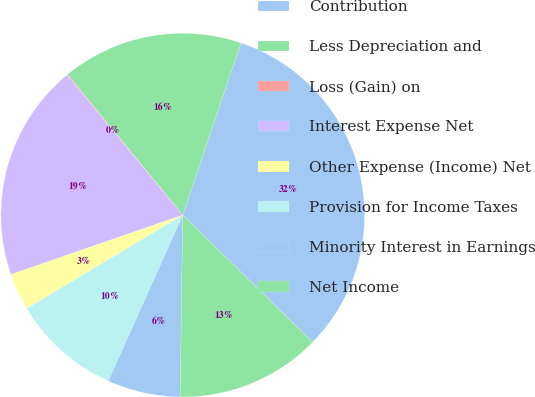<chart> <loc_0><loc_0><loc_500><loc_500><pie_chart><fcel>Contribution<fcel>Less Depreciation and<fcel>Loss (Gain) on<fcel>Interest Expense Net<fcel>Other Expense (Income) Net<fcel>Provision for Income Taxes<fcel>Minority Interest in Earnings<fcel>Net Income<nl><fcel>32.13%<fcel>16.1%<fcel>0.08%<fcel>19.31%<fcel>3.29%<fcel>9.7%<fcel>6.49%<fcel>12.9%<nl></chart> 